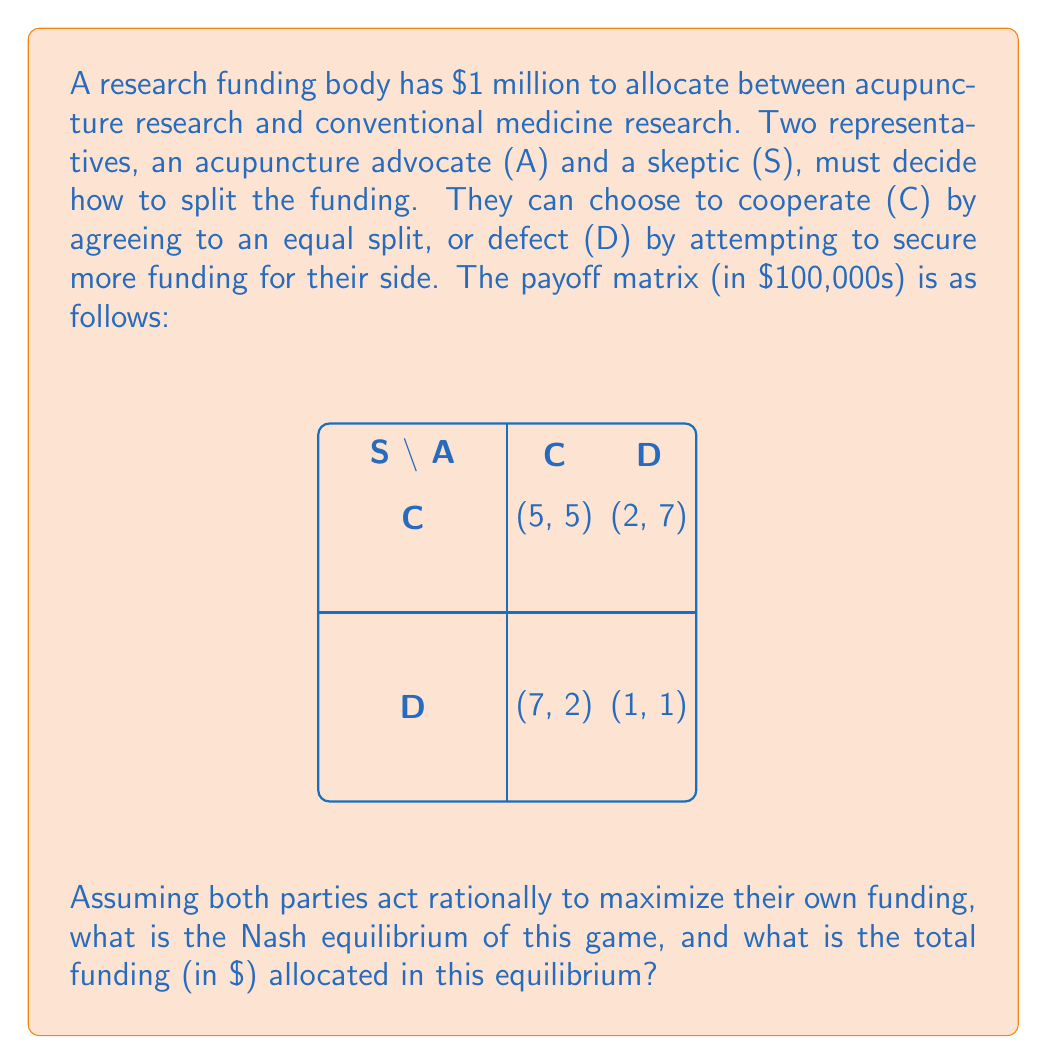Show me your answer to this math problem. To solve this problem, we need to follow these steps:

1) Identify the dominant strategy for each player:

   For the Acupuncture advocate (A):
   - If S chooses C: A gets 5 if C, 7 if D. D is better.
   - If S chooses D: A gets 2 if C, 1 if D. C is better.
   There's no dominant strategy for A.

   For the Skeptic (S):
   - If A chooses C: S gets 5 if C, 7 if D. D is better.
   - If A chooses D: S gets 2 if C, 1 if D. C is better.
   There's no dominant strategy for S.

2) Find the Nash equilibrium:
   A Nash equilibrium occurs when neither player can unilaterally improve their outcome by changing their strategy.

   - If (C,C): S can improve by switching to D
   - If (C,D): A can improve by switching to D
   - If (D,C): S can improve by switching to D
   - If (D,D): Neither can improve by switching

   Therefore, (D,D) is the Nash equilibrium.

3) Calculate the total funding in the Nash equilibrium:
   At (D,D), both A and S receive 1 (in $100,000s).
   Total funding = $100,000 × (1 + 1) = $200,000

Thus, the Nash equilibrium is (D,D), and the total funding allocated in this equilibrium is $200,000.
Answer: (D,D), $200,000 